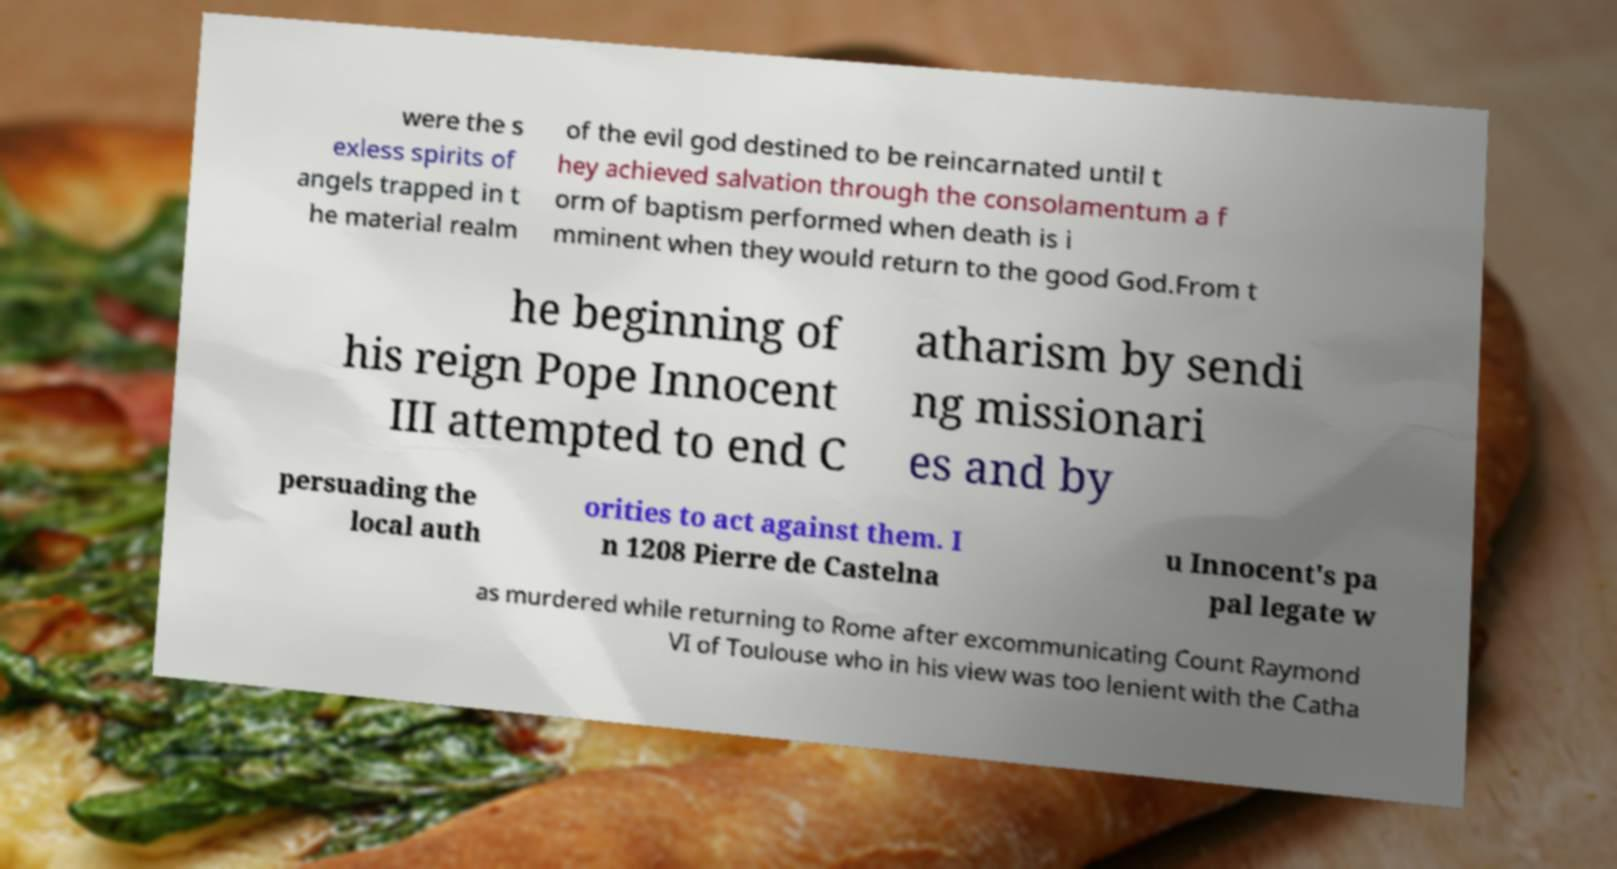There's text embedded in this image that I need extracted. Can you transcribe it verbatim? were the s exless spirits of angels trapped in t he material realm of the evil god destined to be reincarnated until t hey achieved salvation through the consolamentum a f orm of baptism performed when death is i mminent when they would return to the good God.From t he beginning of his reign Pope Innocent III attempted to end C atharism by sendi ng missionari es and by persuading the local auth orities to act against them. I n 1208 Pierre de Castelna u Innocent's pa pal legate w as murdered while returning to Rome after excommunicating Count Raymond VI of Toulouse who in his view was too lenient with the Catha 